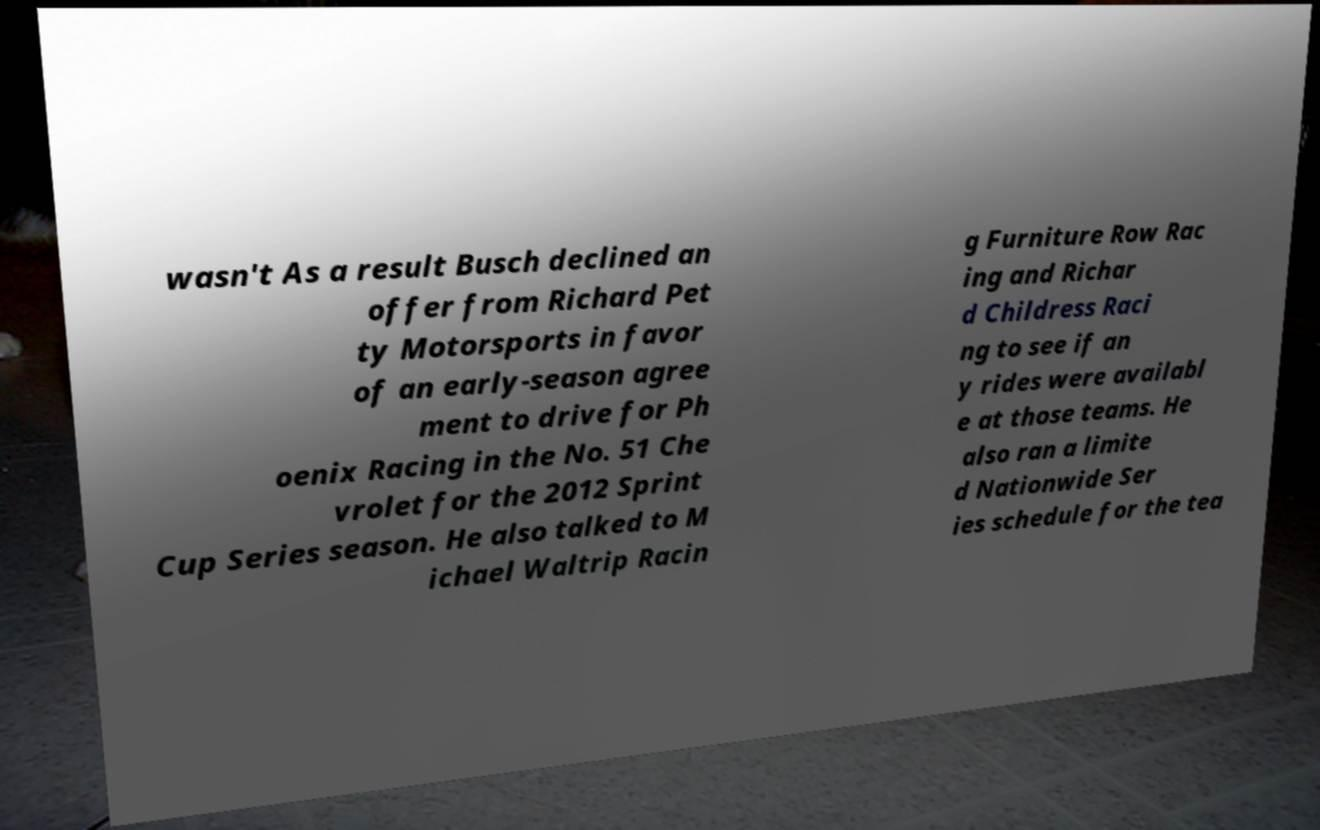Can you read and provide the text displayed in the image?This photo seems to have some interesting text. Can you extract and type it out for me? wasn't As a result Busch declined an offer from Richard Pet ty Motorsports in favor of an early-season agree ment to drive for Ph oenix Racing in the No. 51 Che vrolet for the 2012 Sprint Cup Series season. He also talked to M ichael Waltrip Racin g Furniture Row Rac ing and Richar d Childress Raci ng to see if an y rides were availabl e at those teams. He also ran a limite d Nationwide Ser ies schedule for the tea 